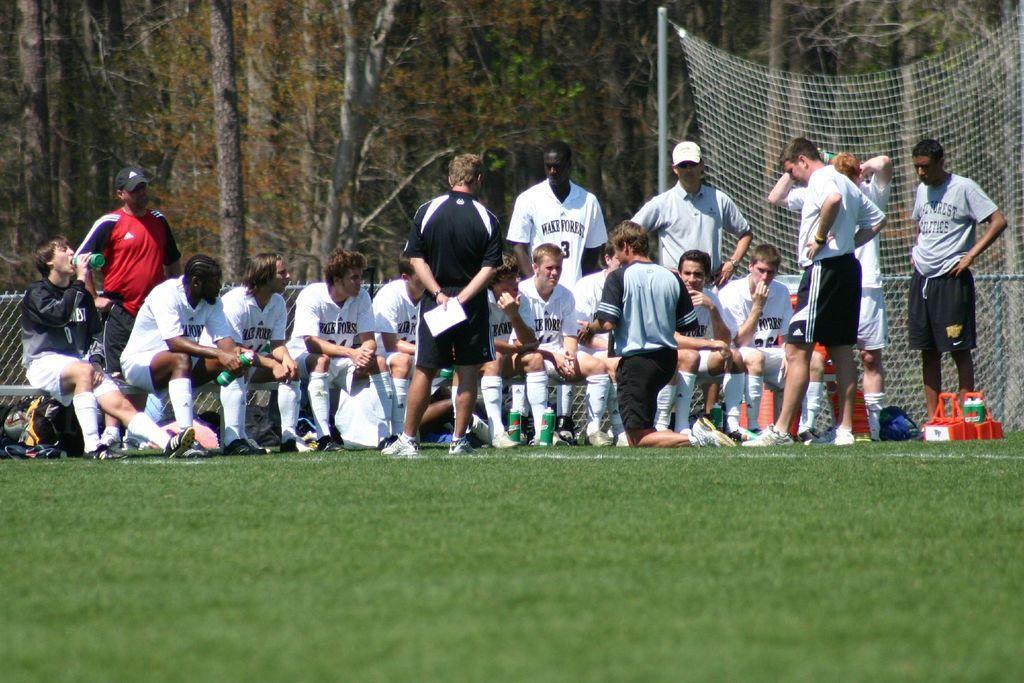How would you summarize this image in a sentence or two? In this image in the front there's grass on the ground. In the background there are persons sitting, standing, there are trees, there is a net, there are objects on the ground which are red and black in colour and there is a person kneeling on the ground and there are bottles and there is a bag. 